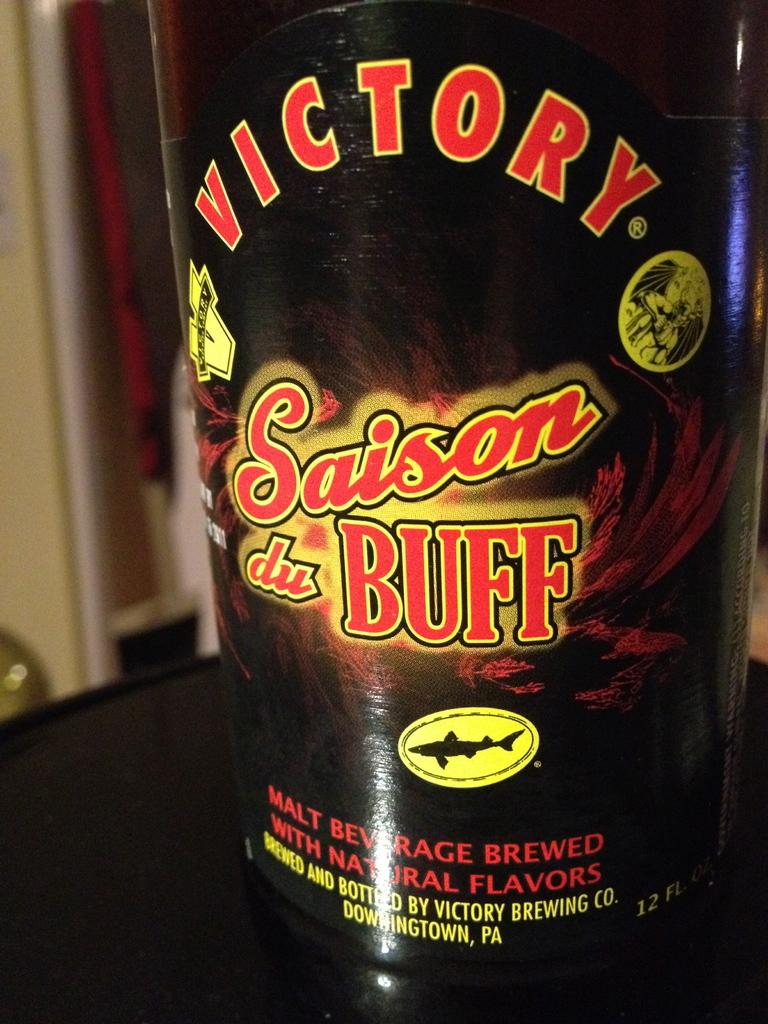What brand is this?
Offer a terse response. Victory. 